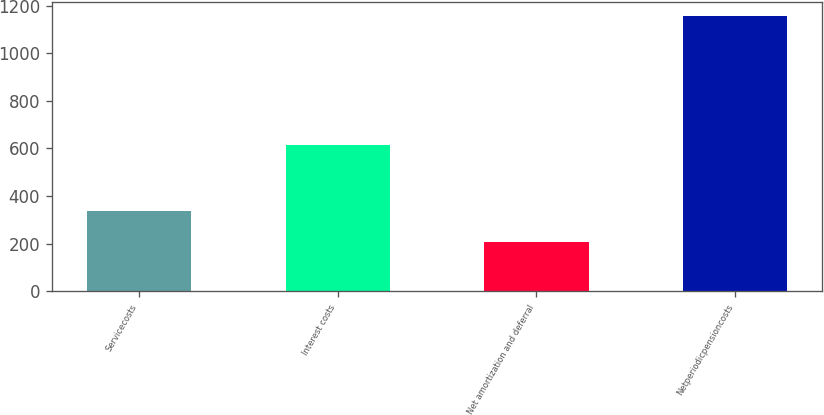Convert chart to OTSL. <chart><loc_0><loc_0><loc_500><loc_500><bar_chart><fcel>Servicecosts<fcel>Interest costs<fcel>Net amortization and deferral<fcel>Netperiodicpensioncosts<nl><fcel>335<fcel>614<fcel>207<fcel>1156<nl></chart> 